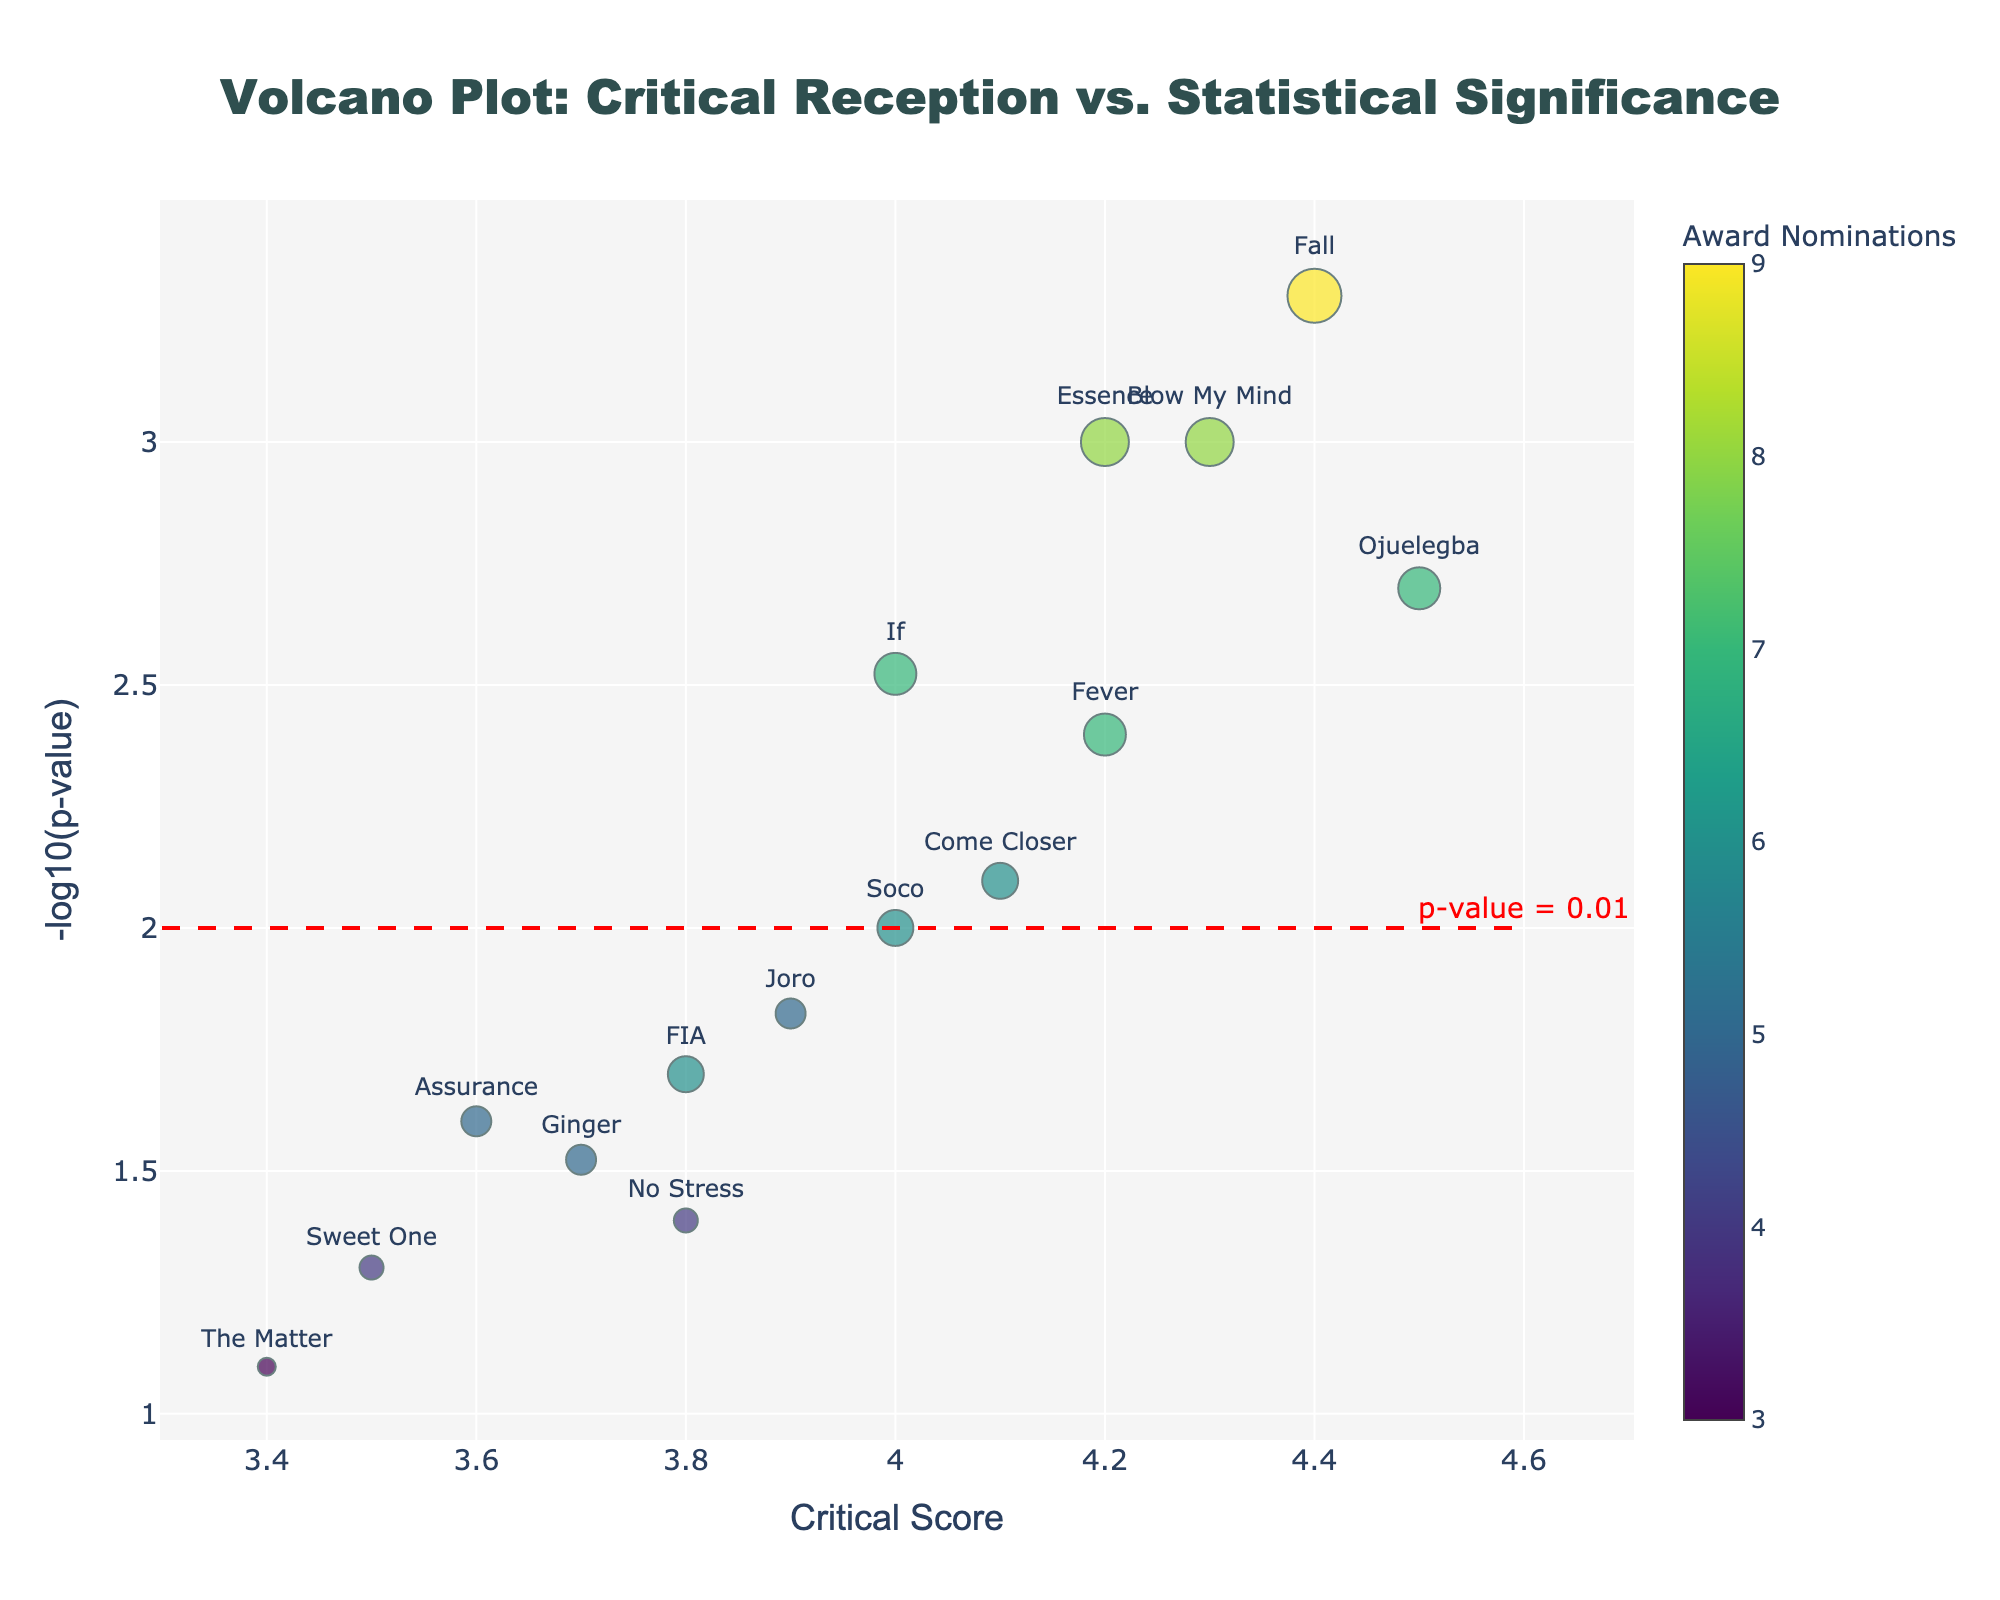What's the title of the volcano plot? The title is usually displayed at the top center of the plot. In this case, the title can be found in the top middle part of the figure.
Answer: Volcano Plot: Critical Reception vs. Statistical Significance What does the horizontal red dashed line represent? The horizontal red dashed line is labeled with "p-value = 0.01", which means it represents the threshold for statistical significance at a p-value of 0.01.
Answer: p-value = 0.01 threshold How many songs have critical scores above 4.0? By observing the x-axis (Critical Score) and finding the points positioned above 4.0, we can see that they are Essence, Ojuelegba, Fall, Blow My Mind, Soco, and Fever, totaling 6 songs.
Answer: 6 songs Which song has the highest critical score and what is it? The song with the highest critical score is positioned furthest to the right along the x-axis. This song is "Ojuelegba" with a critical score of 4.5.
Answer: Ojuelegba, 4.5 Which song has the lowest statistical significance (highest p-value)? The lowest statistical significance corresponds to the lowest -log10(p-value), which is the lowest point on the y-axis in the plot. The song is "The Matter".
Answer: The Matter How many songs fall below the statistical significance threshold of p-value = 0.01? Songs below the threshold will have a -log10(p-value) less than 2. From the plot, there are Joro, FIA, Ginger, Assurance, No Stress, Sweet One, and The Matter, totaling 7 songs.
Answer: 7 songs What is the critical score range of the songs above the statistical significance threshold (p-value < 0.01)? For songs with a -log10(p-value) greater than 2, we observe their x-axis positions. These songs are Essence, Ojuelegba, Come Closer, Fall, If, Blow My Mind, Soco, and Fever. Their critical scores range from 4.0 to 4.5.
Answer: 4.0 to 4.5 Which song has the most award nominations, and how many? Award nominations are represented by the size of the markers. The largest marker on the plot corresponds to the song "Fall", which has 9 award nominations.
Answer: Fall, 9 nominations Compare the critical scores of "Essence" and "Fever". Which song has the higher score? By locating both songs on the x-axis and comparing their positions, "Essence" has a critical score of 4.2 and "Fever" has a critical score of 4.2. Both have the same critical score.
Answer: Both have the same score, 4.2 What is the sum of award nominations for the songs with critical scores below 4.0? First identify the songs with critical scores below 4.0, which are Joro, FIA, Ginger, Sweet One, Assurance, No Stress, and The Matter. Their award nominations are 5, 6, 5, 4, 5, 4, and 3 respectively. Summing these up: 5 + 6 + 5 + 4 + 5 + 4 + 3 = 32.
Answer: 32 nominations 